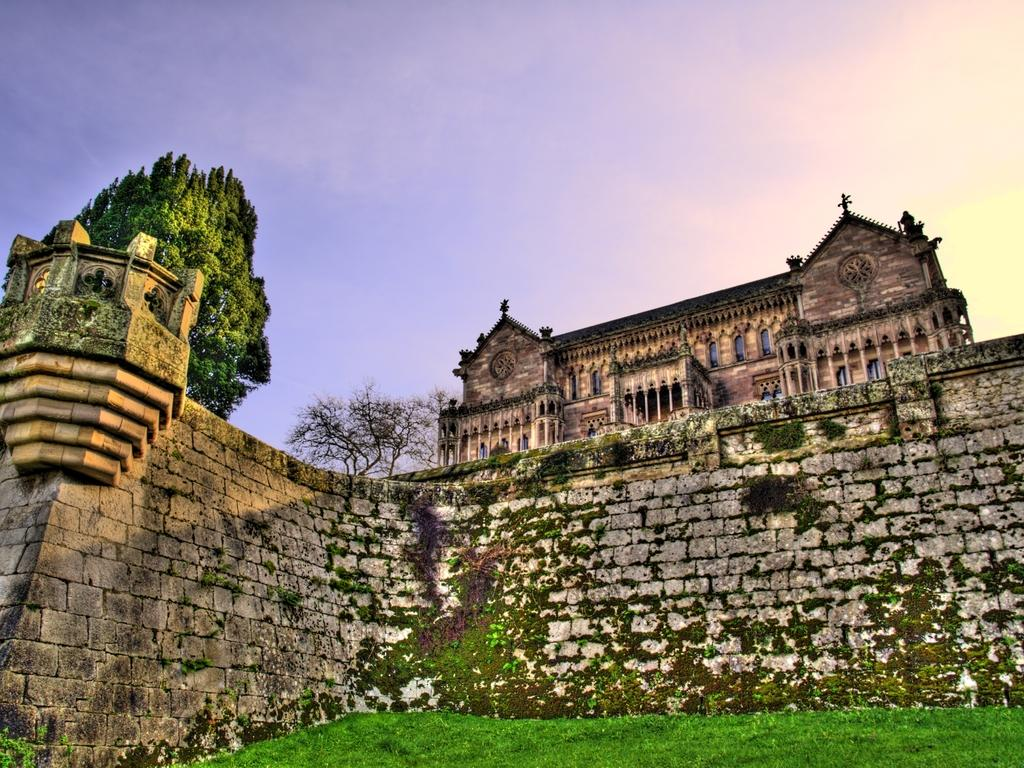What type of vegetation is present on the ground near the wall? There is grass on the ground near a wall. What can be seen in the background of the image? There are trees and a building with glass windows in the background. What is the color of the sky in the image? The sky is blue in the image. Can you tell me where the farm is located in the image? There is no farm present in the image. What type of country is depicted in the image? The image does not depict a specific country; it shows a grassy area with trees and a building in the background. 